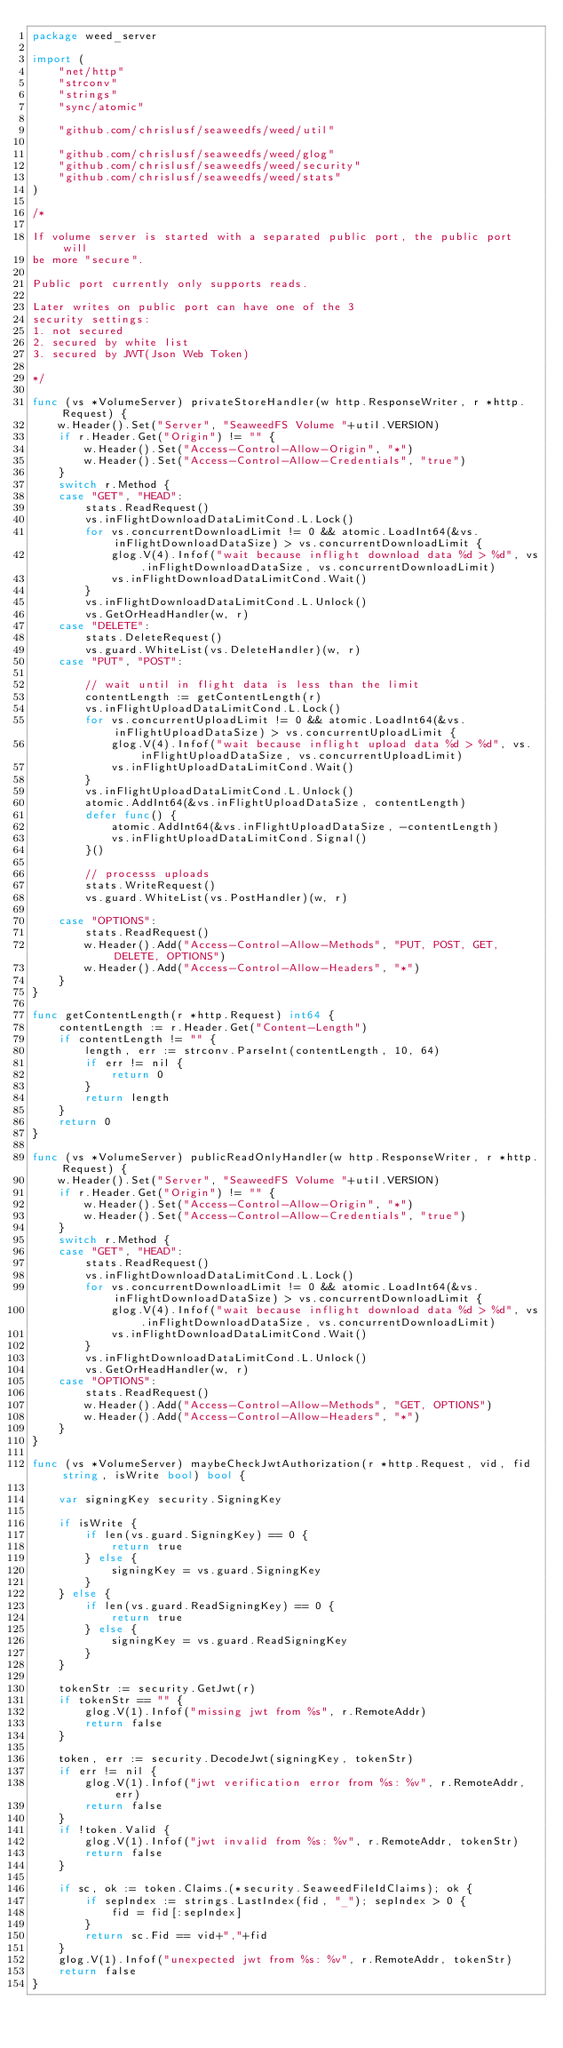Convert code to text. <code><loc_0><loc_0><loc_500><loc_500><_Go_>package weed_server

import (
	"net/http"
	"strconv"
	"strings"
	"sync/atomic"

	"github.com/chrislusf/seaweedfs/weed/util"

	"github.com/chrislusf/seaweedfs/weed/glog"
	"github.com/chrislusf/seaweedfs/weed/security"
	"github.com/chrislusf/seaweedfs/weed/stats"
)

/*

If volume server is started with a separated public port, the public port will
be more "secure".

Public port currently only supports reads.

Later writes on public port can have one of the 3
security settings:
1. not secured
2. secured by white list
3. secured by JWT(Json Web Token)

*/

func (vs *VolumeServer) privateStoreHandler(w http.ResponseWriter, r *http.Request) {
	w.Header().Set("Server", "SeaweedFS Volume "+util.VERSION)
	if r.Header.Get("Origin") != "" {
		w.Header().Set("Access-Control-Allow-Origin", "*")
		w.Header().Set("Access-Control-Allow-Credentials", "true")
	}
	switch r.Method {
	case "GET", "HEAD":
		stats.ReadRequest()
		vs.inFlightDownloadDataLimitCond.L.Lock()
		for vs.concurrentDownloadLimit != 0 && atomic.LoadInt64(&vs.inFlightDownloadDataSize) > vs.concurrentDownloadLimit {
			glog.V(4).Infof("wait because inflight download data %d > %d", vs.inFlightDownloadDataSize, vs.concurrentDownloadLimit)
			vs.inFlightDownloadDataLimitCond.Wait()
		}
		vs.inFlightDownloadDataLimitCond.L.Unlock()
		vs.GetOrHeadHandler(w, r)
	case "DELETE":
		stats.DeleteRequest()
		vs.guard.WhiteList(vs.DeleteHandler)(w, r)
	case "PUT", "POST":

		// wait until in flight data is less than the limit
		contentLength := getContentLength(r)
		vs.inFlightUploadDataLimitCond.L.Lock()
		for vs.concurrentUploadLimit != 0 && atomic.LoadInt64(&vs.inFlightUploadDataSize) > vs.concurrentUploadLimit {
			glog.V(4).Infof("wait because inflight upload data %d > %d", vs.inFlightUploadDataSize, vs.concurrentUploadLimit)
			vs.inFlightUploadDataLimitCond.Wait()
		}
		vs.inFlightUploadDataLimitCond.L.Unlock()
		atomic.AddInt64(&vs.inFlightUploadDataSize, contentLength)
		defer func() {
			atomic.AddInt64(&vs.inFlightUploadDataSize, -contentLength)
			vs.inFlightUploadDataLimitCond.Signal()
		}()

		// processs uploads
		stats.WriteRequest()
		vs.guard.WhiteList(vs.PostHandler)(w, r)

	case "OPTIONS":
		stats.ReadRequest()
		w.Header().Add("Access-Control-Allow-Methods", "PUT, POST, GET, DELETE, OPTIONS")
		w.Header().Add("Access-Control-Allow-Headers", "*")
	}
}

func getContentLength(r *http.Request) int64 {
	contentLength := r.Header.Get("Content-Length")
	if contentLength != "" {
		length, err := strconv.ParseInt(contentLength, 10, 64)
		if err != nil {
			return 0
		}
		return length
	}
	return 0
}

func (vs *VolumeServer) publicReadOnlyHandler(w http.ResponseWriter, r *http.Request) {
	w.Header().Set("Server", "SeaweedFS Volume "+util.VERSION)
	if r.Header.Get("Origin") != "" {
		w.Header().Set("Access-Control-Allow-Origin", "*")
		w.Header().Set("Access-Control-Allow-Credentials", "true")
	}
	switch r.Method {
	case "GET", "HEAD":
		stats.ReadRequest()
		vs.inFlightDownloadDataLimitCond.L.Lock()
		for vs.concurrentDownloadLimit != 0 && atomic.LoadInt64(&vs.inFlightDownloadDataSize) > vs.concurrentDownloadLimit {
			glog.V(4).Infof("wait because inflight download data %d > %d", vs.inFlightDownloadDataSize, vs.concurrentDownloadLimit)
			vs.inFlightDownloadDataLimitCond.Wait()
		}
		vs.inFlightDownloadDataLimitCond.L.Unlock()
		vs.GetOrHeadHandler(w, r)
	case "OPTIONS":
		stats.ReadRequest()
		w.Header().Add("Access-Control-Allow-Methods", "GET, OPTIONS")
		w.Header().Add("Access-Control-Allow-Headers", "*")
	}
}

func (vs *VolumeServer) maybeCheckJwtAuthorization(r *http.Request, vid, fid string, isWrite bool) bool {

	var signingKey security.SigningKey

	if isWrite {
		if len(vs.guard.SigningKey) == 0 {
			return true
		} else {
			signingKey = vs.guard.SigningKey
		}
	} else {
		if len(vs.guard.ReadSigningKey) == 0 {
			return true
		} else {
			signingKey = vs.guard.ReadSigningKey
		}
	}

	tokenStr := security.GetJwt(r)
	if tokenStr == "" {
		glog.V(1).Infof("missing jwt from %s", r.RemoteAddr)
		return false
	}

	token, err := security.DecodeJwt(signingKey, tokenStr)
	if err != nil {
		glog.V(1).Infof("jwt verification error from %s: %v", r.RemoteAddr, err)
		return false
	}
	if !token.Valid {
		glog.V(1).Infof("jwt invalid from %s: %v", r.RemoteAddr, tokenStr)
		return false
	}

	if sc, ok := token.Claims.(*security.SeaweedFileIdClaims); ok {
		if sepIndex := strings.LastIndex(fid, "_"); sepIndex > 0 {
			fid = fid[:sepIndex]
		}
		return sc.Fid == vid+","+fid
	}
	glog.V(1).Infof("unexpected jwt from %s: %v", r.RemoteAddr, tokenStr)
	return false
}
</code> 